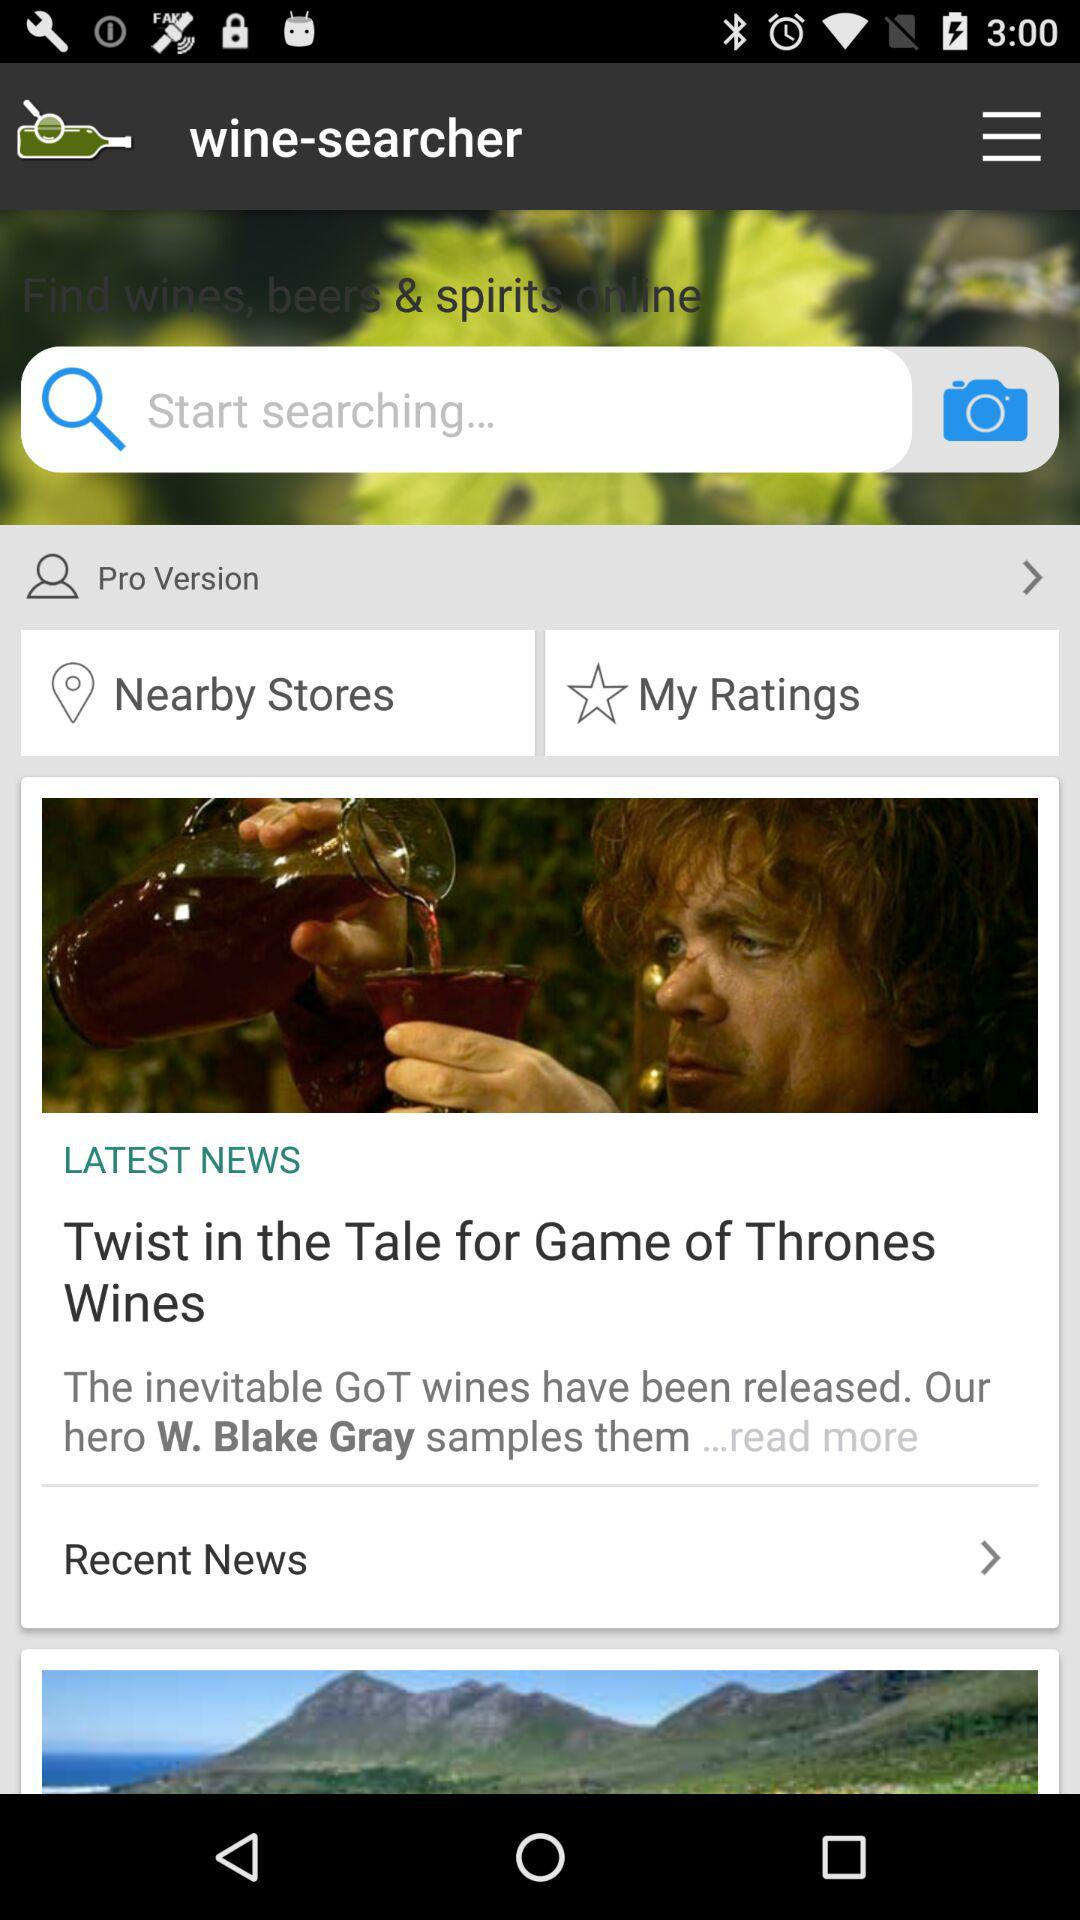What is the name of the application? The application name is "wine-searcher". 